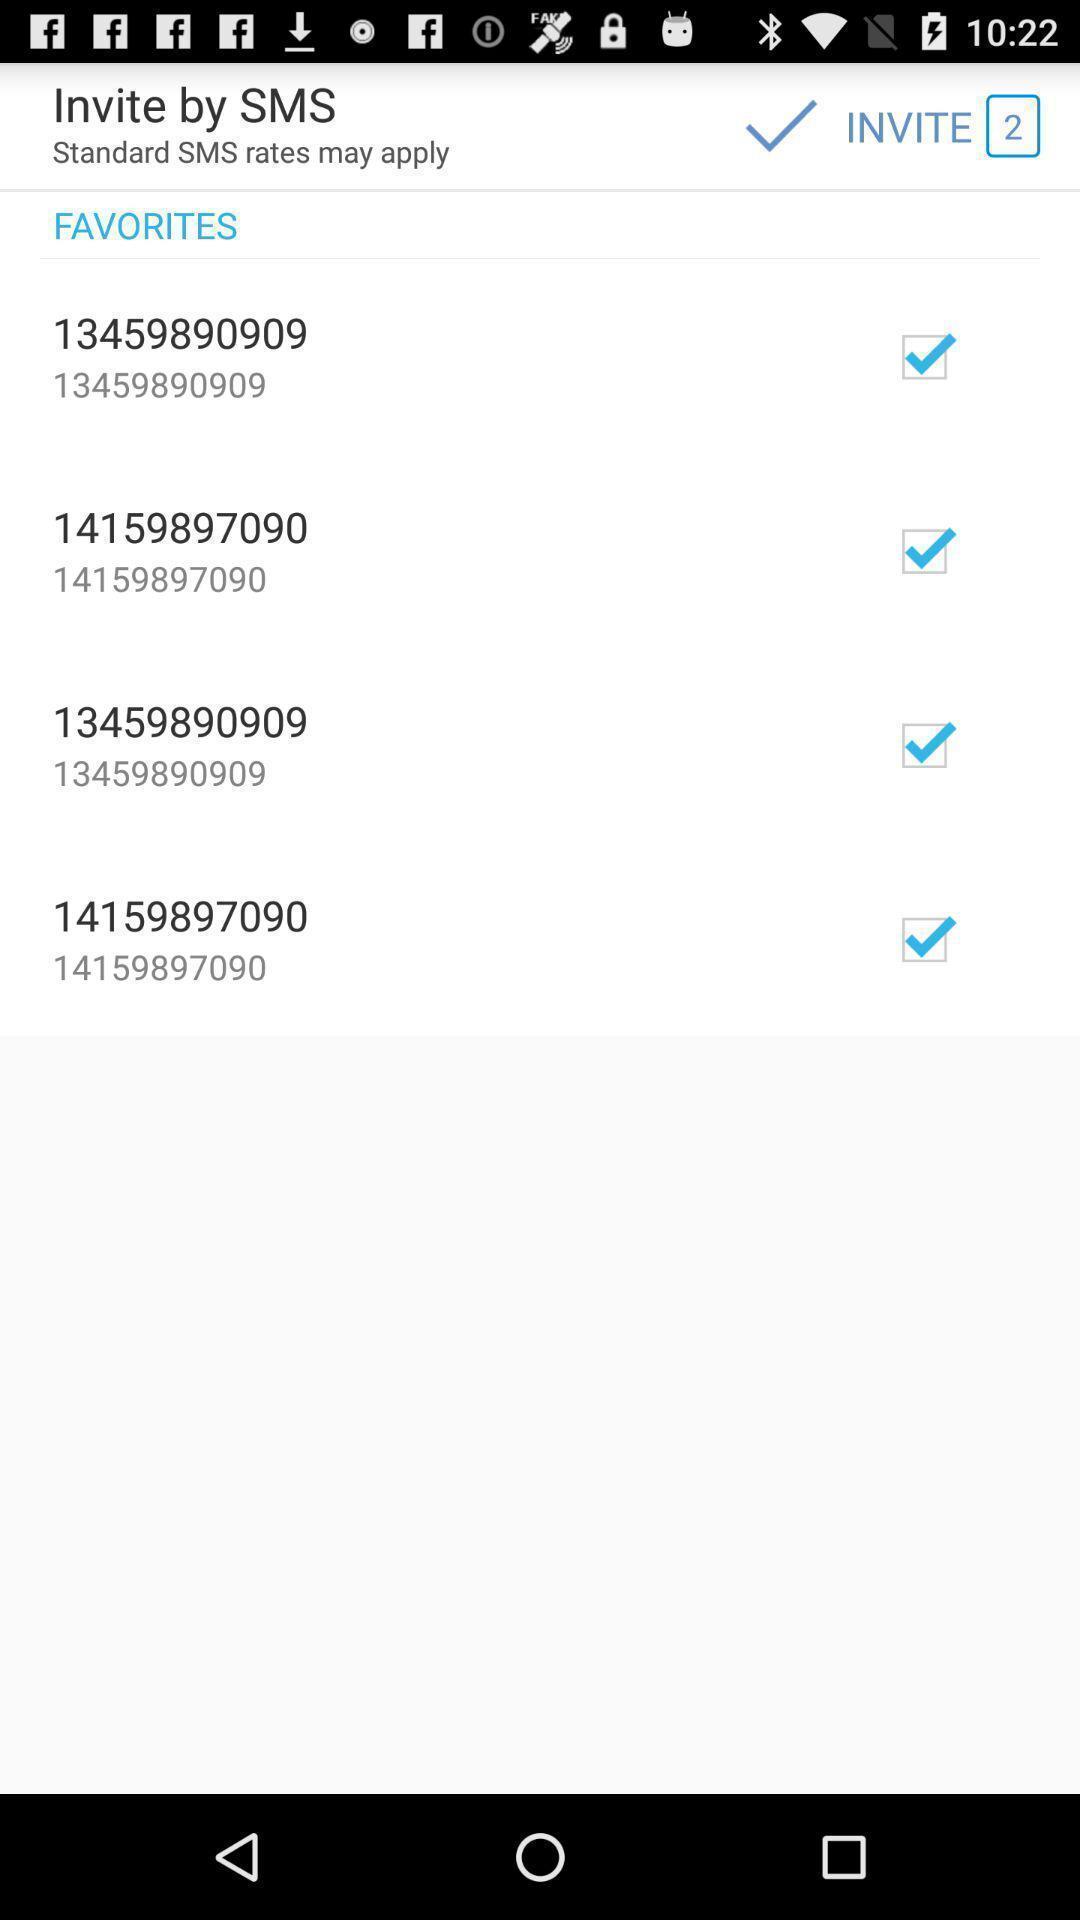Describe the content in this image. Screen displaying invitation to favorites. 